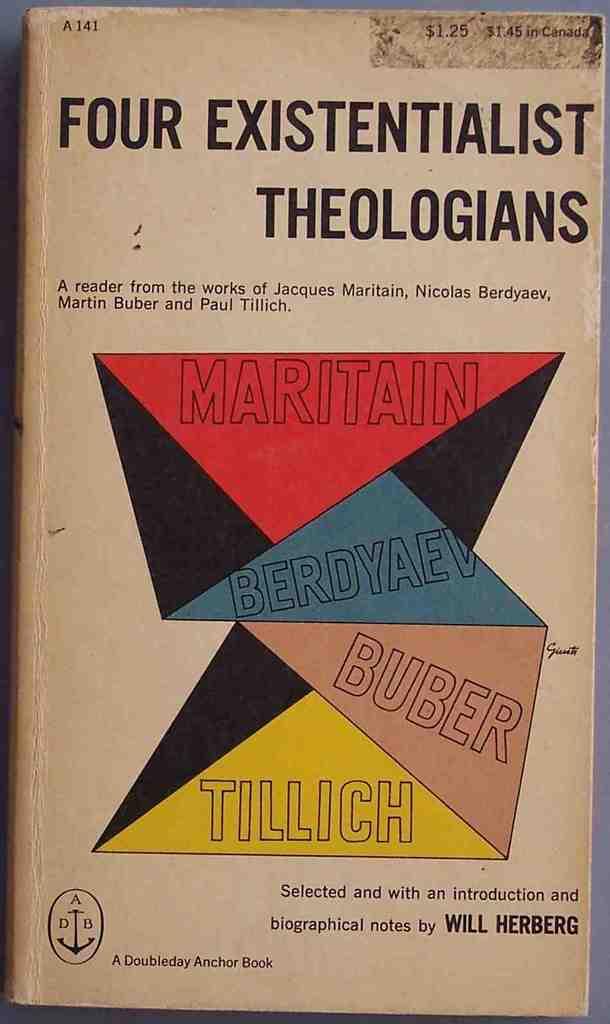Who wrote the introduction?
Your answer should be very brief. Will herberg. What is the title of the book?
Your response must be concise. Four existentialist theologians. 